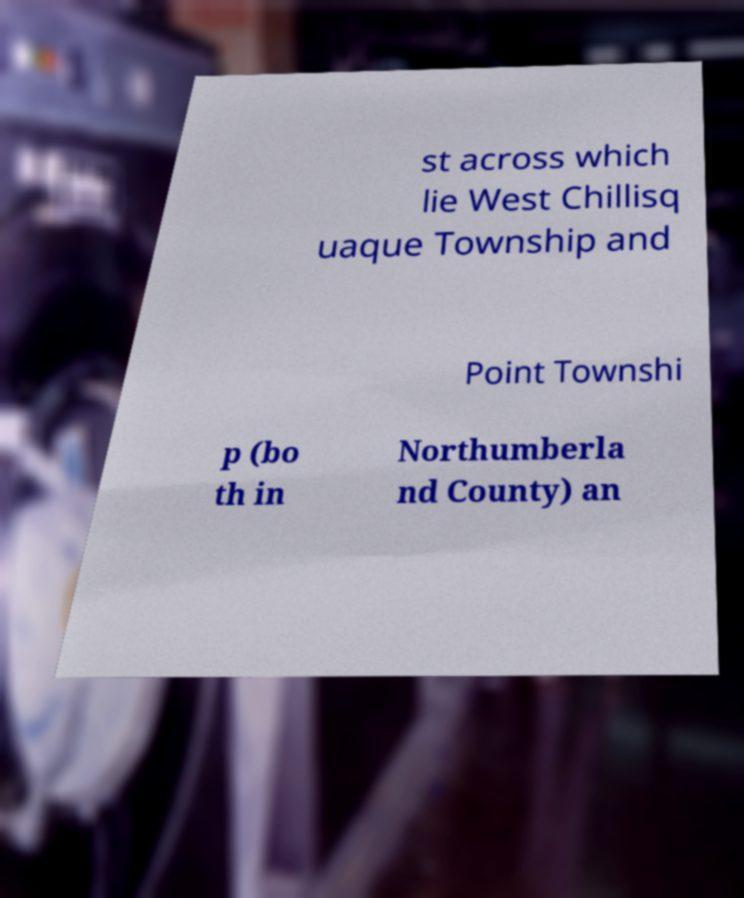Please read and relay the text visible in this image. What does it say? st across which lie West Chillisq uaque Township and Point Townshi p (bo th in Northumberla nd County) an 